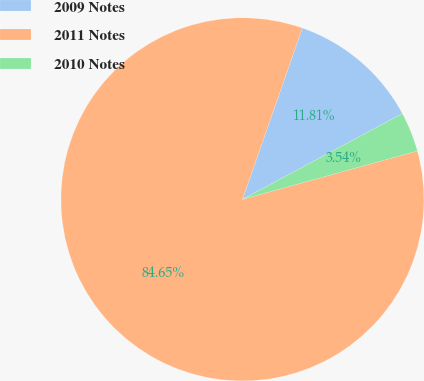Convert chart to OTSL. <chart><loc_0><loc_0><loc_500><loc_500><pie_chart><fcel>2009 Notes<fcel>2011 Notes<fcel>2010 Notes<nl><fcel>11.81%<fcel>84.65%<fcel>3.54%<nl></chart> 